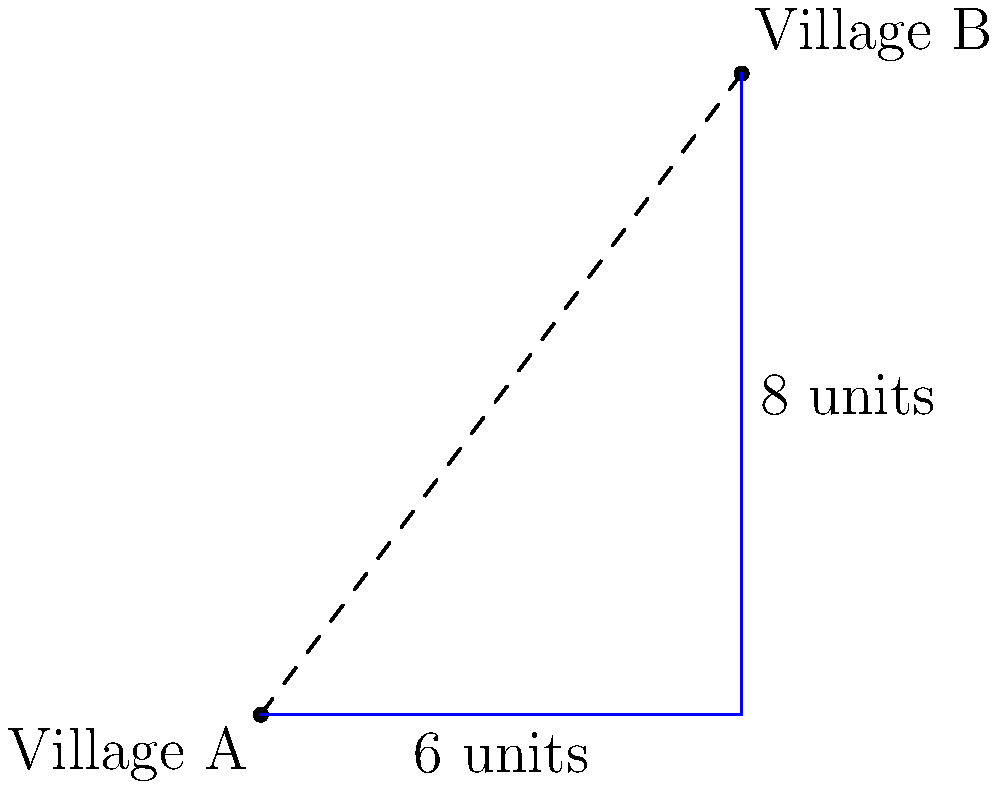In your tribal land, two neighboring villages are located at different points on a coordinate system. Village A is at the origin (0,0), and Village B is at coordinates (6,8). Using the distance formula, calculate the shortest distance between these two villages. How might this information help in planning a new path connecting the villages? To find the distance between two points, we use the distance formula:

$$d = \sqrt{(x_2-x_1)^2 + (y_2-y_1)^2}$$

Where $(x_1,y_1)$ is the coordinate of Village A and $(x_2,y_2)$ is the coordinate of Village B.

Step 1: Identify the coordinates
Village A: $(x_1,y_1) = (0,0)$
Village B: $(x_2,y_2) = (6,8)$

Step 2: Plug the values into the formula
$$d = \sqrt{(6-0)^2 + (8-0)^2}$$

Step 3: Simplify
$$d = \sqrt{6^2 + 8^2}$$
$$d = \sqrt{36 + 64}$$
$$d = \sqrt{100}$$

Step 4: Calculate the final answer
$$d = 10$$

The shortest distance between the two villages is 10 units.

This information can help in planning a direct path between the villages, which would be shorter than following the existing routes along the coordinate axes (6 units east and 8 units north). This direct path could save time and resources for travelers and potentially strengthen connections between the villages.
Answer: 10 units 